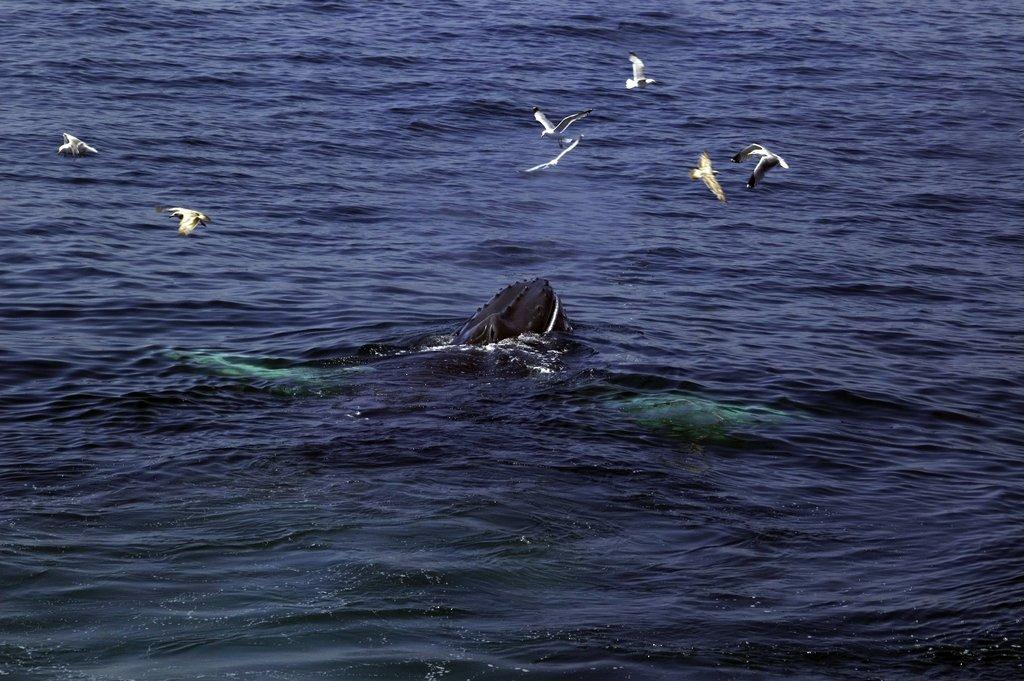What is present at the bottom of the image? There is water at the bottom of the image. What is happening in the sky in the image? There are birds flying in the image. What type of music can be heard playing in the background of the image? There is no music present in the image, as it features water and birds flying. What type of base is supporting the birds in the image? The birds are flying, so there is no base supporting them in the image. 